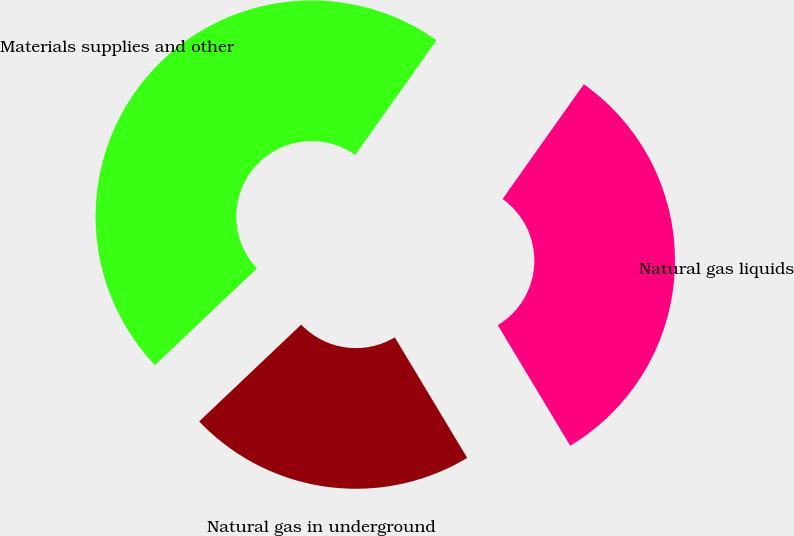Convert chart to OTSL. <chart><loc_0><loc_0><loc_500><loc_500><pie_chart><fcel>Natural gas liquids<fcel>Natural gas in underground<fcel>Materials supplies and other<nl><fcel>31.58%<fcel>21.53%<fcel>46.89%<nl></chart> 